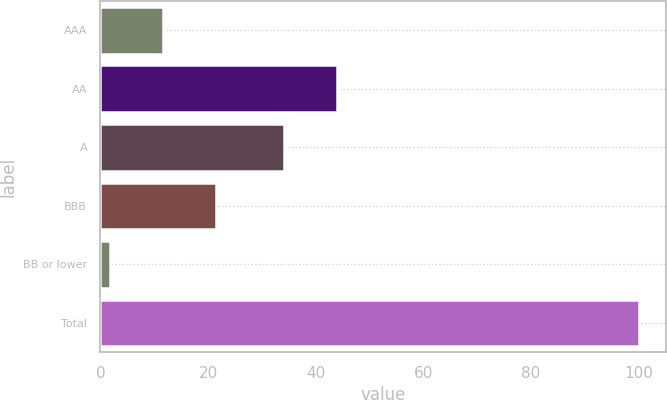Convert chart to OTSL. <chart><loc_0><loc_0><loc_500><loc_500><bar_chart><fcel>AAA<fcel>AA<fcel>A<fcel>BBB<fcel>BB or lower<fcel>Total<nl><fcel>11.62<fcel>43.92<fcel>34.1<fcel>21.44<fcel>1.8<fcel>100<nl></chart> 